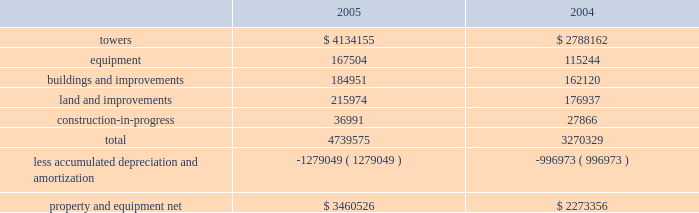American tower corporation and subsidiaries notes to consolidated financial statements 2014 ( continued ) operations , net , in the accompanying consolidated statements of operations for the year ended december 31 , 2003 .
( see note 9. ) other transactions 2014in august 2003 , the company consummated the sale of galaxy engineering ( galaxy ) , a radio frequency engineering , network design and tower-related consulting business ( previously included in the company 2019s network development services segment ) .
The purchase price of approximately $ 3.5 million included $ 2.0 million in cash , which the company received at closing , and an additional $ 1.5 million payable on january 15 , 2008 , or at an earlier date based on the future revenues of galaxy .
The company received $ 0.5 million of this amount in january 2005 .
Pursuant to this transaction , the company recorded a net loss on disposal of approximately $ 2.4 million in the accompanying consolidated statement of operations for the year ended december 31 , 2003 .
In may 2003 , the company consummated the sale of an office building in westwood , massachusetts ( previously held primarily as rental property and included in the company 2019s rental and management segment ) for a purchase price of approximately $ 18.5 million , including $ 2.4 million of cash proceeds and the buyer 2019s assumption of $ 16.1 million of related mortgage notes .
Pursuant to this transaction , the company recorded a net loss on disposal of approximately $ 3.6 million in the accompanying consolidated statement of operations for the year ended december 31 , 2003 .
In january 2003 , the company consummated the sale of flash technologies , its remaining components business ( previously included in the company 2019s network development services segment ) for approximately $ 35.5 million in cash and has recorded a net gain on disposal of approximately $ 0.1 million in the accompanying consolidated statement of operations for the year ended december 31 , 2003 .
In march 2003 , the company consummated the sale of an office building in schaumburg , illinois ( previously held primarily as rental property and included in the company 2019s rental and management segment ) for net proceeds of approximately $ 10.3 million in cash and recorded a net loss on disposal of $ 0.1 million in the accompanying consolidated statement of operations for the year ended december 31 , 2003 .
Property and equipment property and equipment ( including assets held under capital leases ) consist of the following as of december 31 , ( in thousands ) : .
Goodwill and other intangible assets the company 2019s net carrying amount of goodwill was approximately $ 2.1 billion as of december 312005 and $ 592.7 million as of december 31 , 2004 , all of which related to its rental and management segment .
The increase in the carrying value was as a result of the goodwill of $ 1.5 billion acquired in the merger with spectrasite , inc .
( see note 2. ) .
In march 2003 what was the percentage of the loss recorded on the company consummated the sale of an office building in schaumburg,? 
Computations: (0.1 / 10.3)
Answer: 0.00971. 